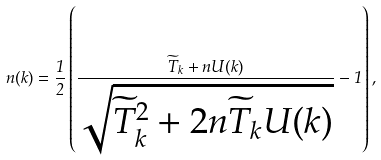<formula> <loc_0><loc_0><loc_500><loc_500>n ( k ) = \frac { 1 } { 2 } \left ( \frac { \widetilde { T } _ { k } + n U ( k ) } { \sqrt { \widetilde { T } _ { k } ^ { 2 } + 2 n \widetilde { T } _ { k } U ( k ) } } - 1 \right ) ,</formula> 